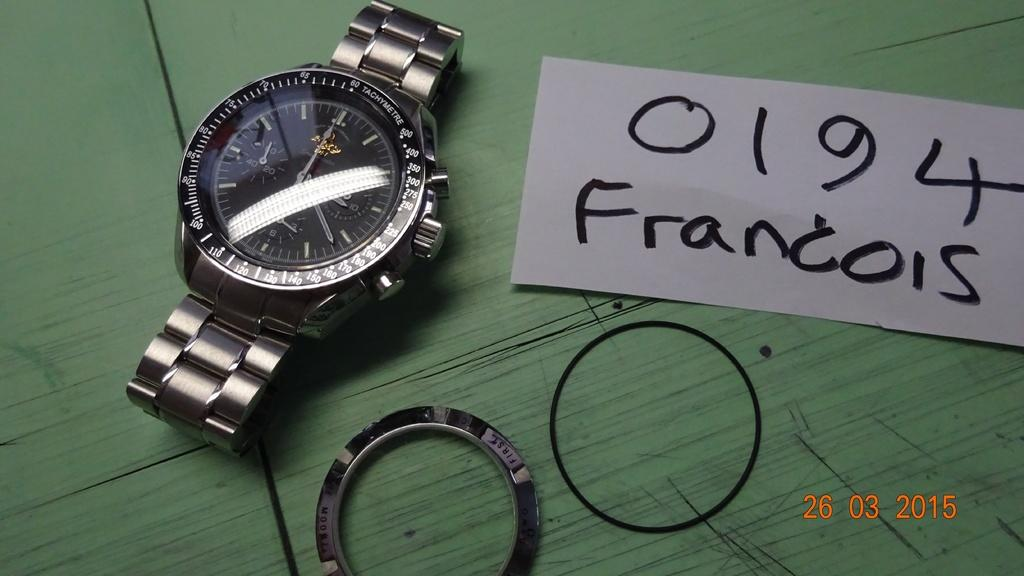<image>
Share a concise interpretation of the image provided. A watch has a hand written note next to it with the word Francois. 